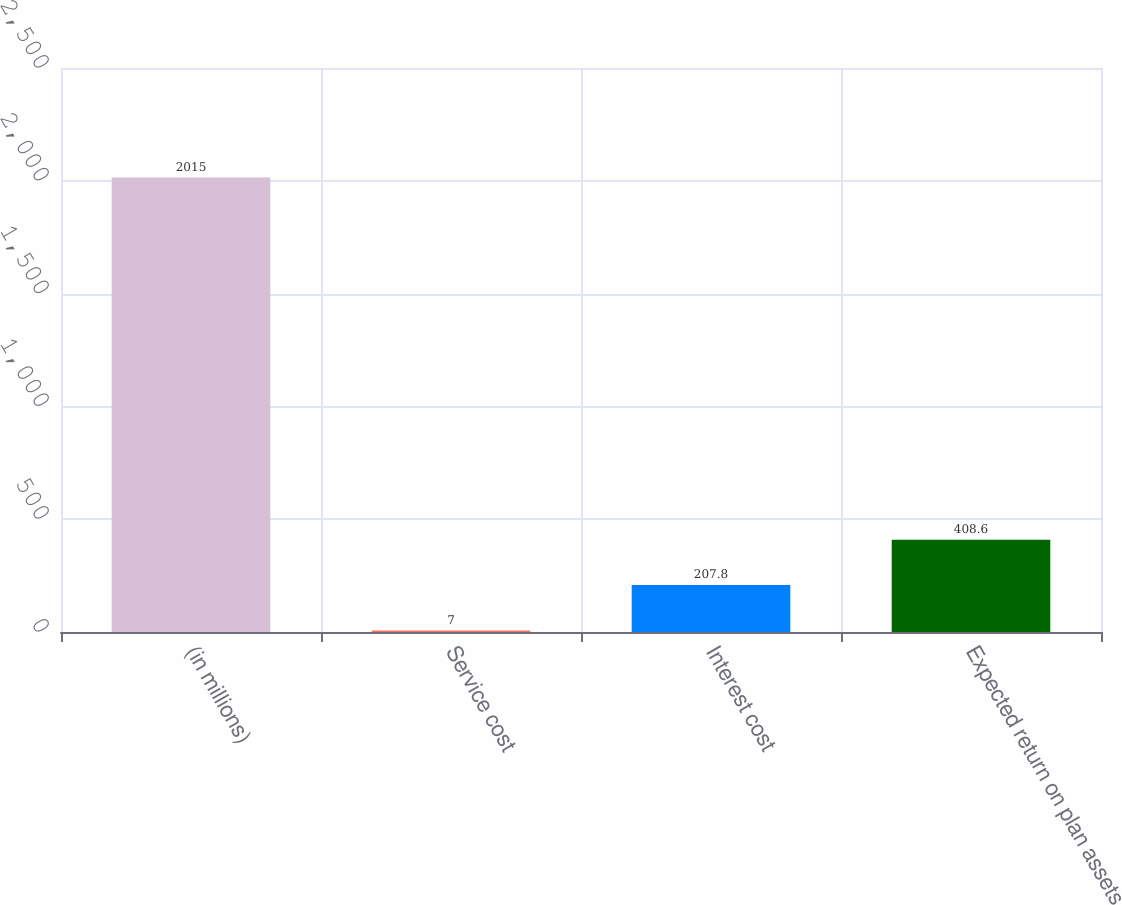Convert chart to OTSL. <chart><loc_0><loc_0><loc_500><loc_500><bar_chart><fcel>(in millions)<fcel>Service cost<fcel>Interest cost<fcel>Expected return on plan assets<nl><fcel>2015<fcel>7<fcel>207.8<fcel>408.6<nl></chart> 